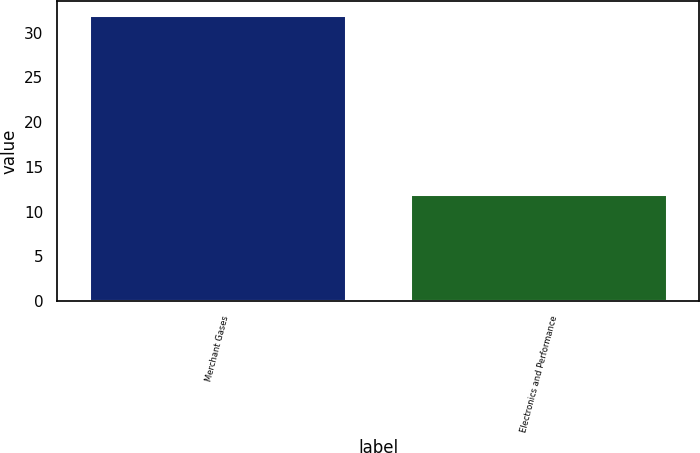Convert chart. <chart><loc_0><loc_0><loc_500><loc_500><bar_chart><fcel>Merchant Gases<fcel>Electronics and Performance<nl><fcel>32<fcel>12<nl></chart> 